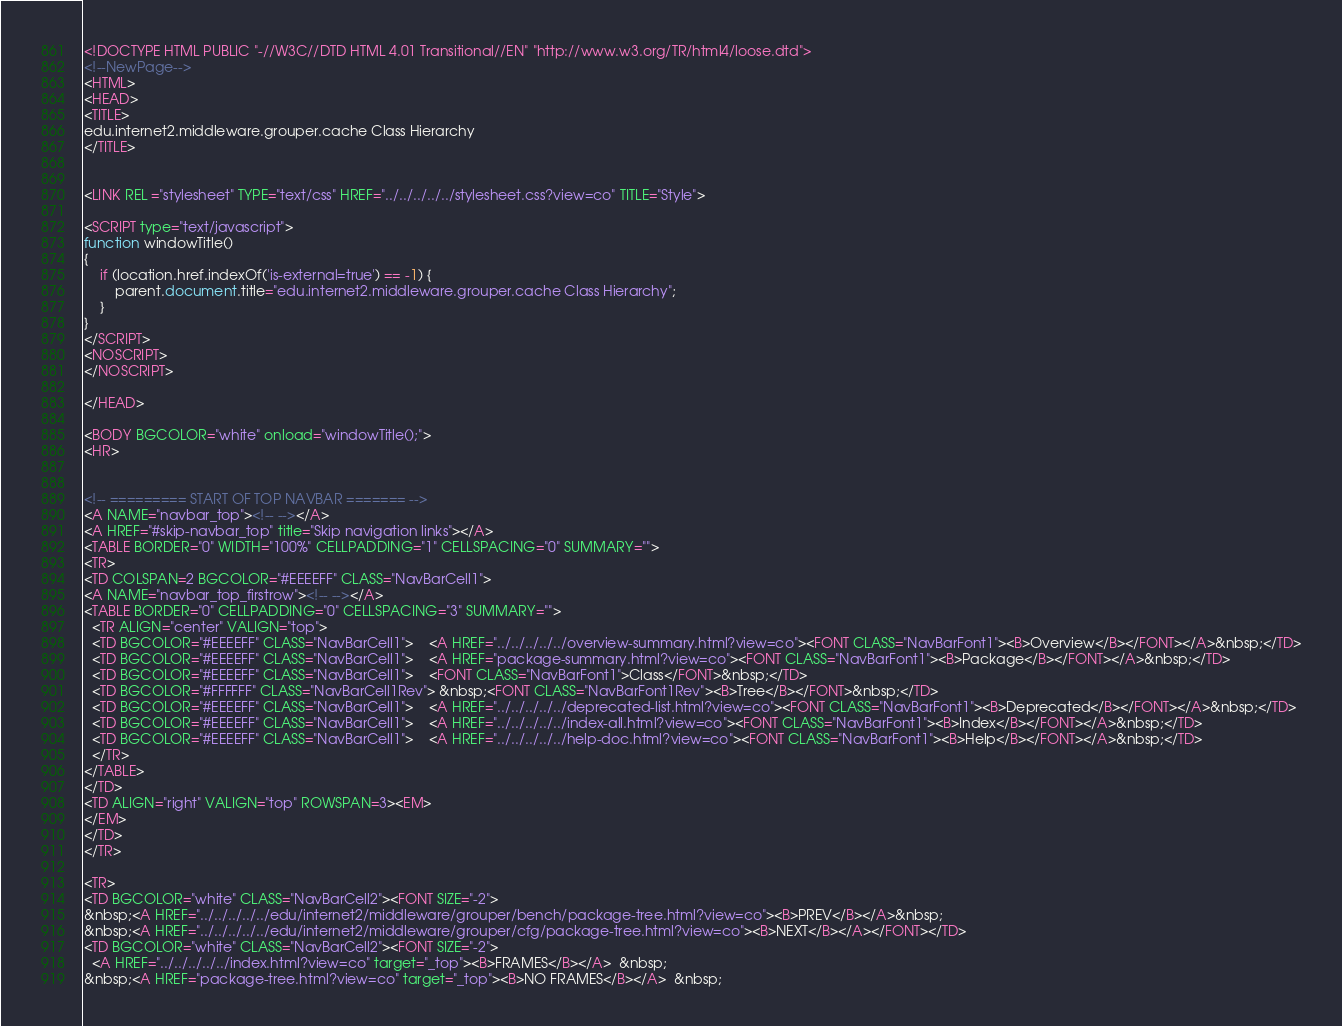Convert code to text. <code><loc_0><loc_0><loc_500><loc_500><_HTML_><!DOCTYPE HTML PUBLIC "-//W3C//DTD HTML 4.01 Transitional//EN" "http://www.w3.org/TR/html4/loose.dtd">
<!--NewPage-->
<HTML>
<HEAD>
<TITLE>
edu.internet2.middleware.grouper.cache Class Hierarchy
</TITLE>


<LINK REL ="stylesheet" TYPE="text/css" HREF="../../../../../stylesheet.css?view=co" TITLE="Style">

<SCRIPT type="text/javascript">
function windowTitle()
{
    if (location.href.indexOf('is-external=true') == -1) {
        parent.document.title="edu.internet2.middleware.grouper.cache Class Hierarchy";
    }
}
</SCRIPT>
<NOSCRIPT>
</NOSCRIPT>

</HEAD>

<BODY BGCOLOR="white" onload="windowTitle();">
<HR>


<!-- ========= START OF TOP NAVBAR ======= -->
<A NAME="navbar_top"><!-- --></A>
<A HREF="#skip-navbar_top" title="Skip navigation links"></A>
<TABLE BORDER="0" WIDTH="100%" CELLPADDING="1" CELLSPACING="0" SUMMARY="">
<TR>
<TD COLSPAN=2 BGCOLOR="#EEEEFF" CLASS="NavBarCell1">
<A NAME="navbar_top_firstrow"><!-- --></A>
<TABLE BORDER="0" CELLPADDING="0" CELLSPACING="3" SUMMARY="">
  <TR ALIGN="center" VALIGN="top">
  <TD BGCOLOR="#EEEEFF" CLASS="NavBarCell1">    <A HREF="../../../../../overview-summary.html?view=co"><FONT CLASS="NavBarFont1"><B>Overview</B></FONT></A>&nbsp;</TD>
  <TD BGCOLOR="#EEEEFF" CLASS="NavBarCell1">    <A HREF="package-summary.html?view=co"><FONT CLASS="NavBarFont1"><B>Package</B></FONT></A>&nbsp;</TD>
  <TD BGCOLOR="#EEEEFF" CLASS="NavBarCell1">    <FONT CLASS="NavBarFont1">Class</FONT>&nbsp;</TD>
  <TD BGCOLOR="#FFFFFF" CLASS="NavBarCell1Rev"> &nbsp;<FONT CLASS="NavBarFont1Rev"><B>Tree</B></FONT>&nbsp;</TD>
  <TD BGCOLOR="#EEEEFF" CLASS="NavBarCell1">    <A HREF="../../../../../deprecated-list.html?view=co"><FONT CLASS="NavBarFont1"><B>Deprecated</B></FONT></A>&nbsp;</TD>
  <TD BGCOLOR="#EEEEFF" CLASS="NavBarCell1">    <A HREF="../../../../../index-all.html?view=co"><FONT CLASS="NavBarFont1"><B>Index</B></FONT></A>&nbsp;</TD>
  <TD BGCOLOR="#EEEEFF" CLASS="NavBarCell1">    <A HREF="../../../../../help-doc.html?view=co"><FONT CLASS="NavBarFont1"><B>Help</B></FONT></A>&nbsp;</TD>
  </TR>
</TABLE>
</TD>
<TD ALIGN="right" VALIGN="top" ROWSPAN=3><EM>
</EM>
</TD>
</TR>

<TR>
<TD BGCOLOR="white" CLASS="NavBarCell2"><FONT SIZE="-2">
&nbsp;<A HREF="../../../../../edu/internet2/middleware/grouper/bench/package-tree.html?view=co"><B>PREV</B></A>&nbsp;
&nbsp;<A HREF="../../../../../edu/internet2/middleware/grouper/cfg/package-tree.html?view=co"><B>NEXT</B></A></FONT></TD>
<TD BGCOLOR="white" CLASS="NavBarCell2"><FONT SIZE="-2">
  <A HREF="../../../../../index.html?view=co" target="_top"><B>FRAMES</B></A>  &nbsp;
&nbsp;<A HREF="package-tree.html?view=co" target="_top"><B>NO FRAMES</B></A>  &nbsp;</code> 